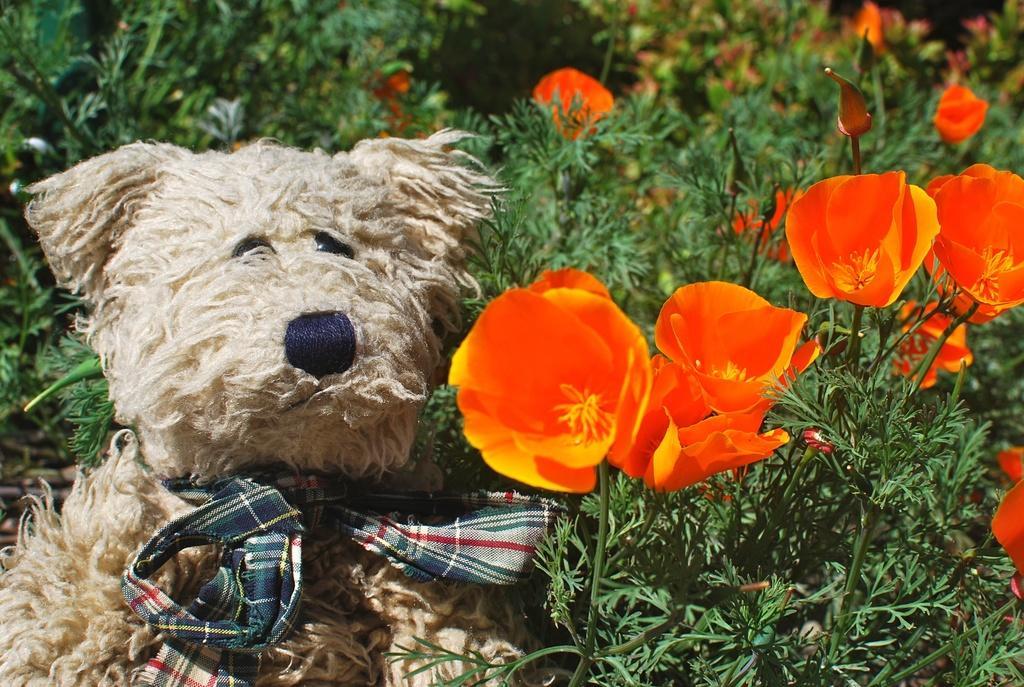Please provide a concise description of this image. In this picture there is a teddy bear on the left side of the image and there are flower plants on the right side of the image. 